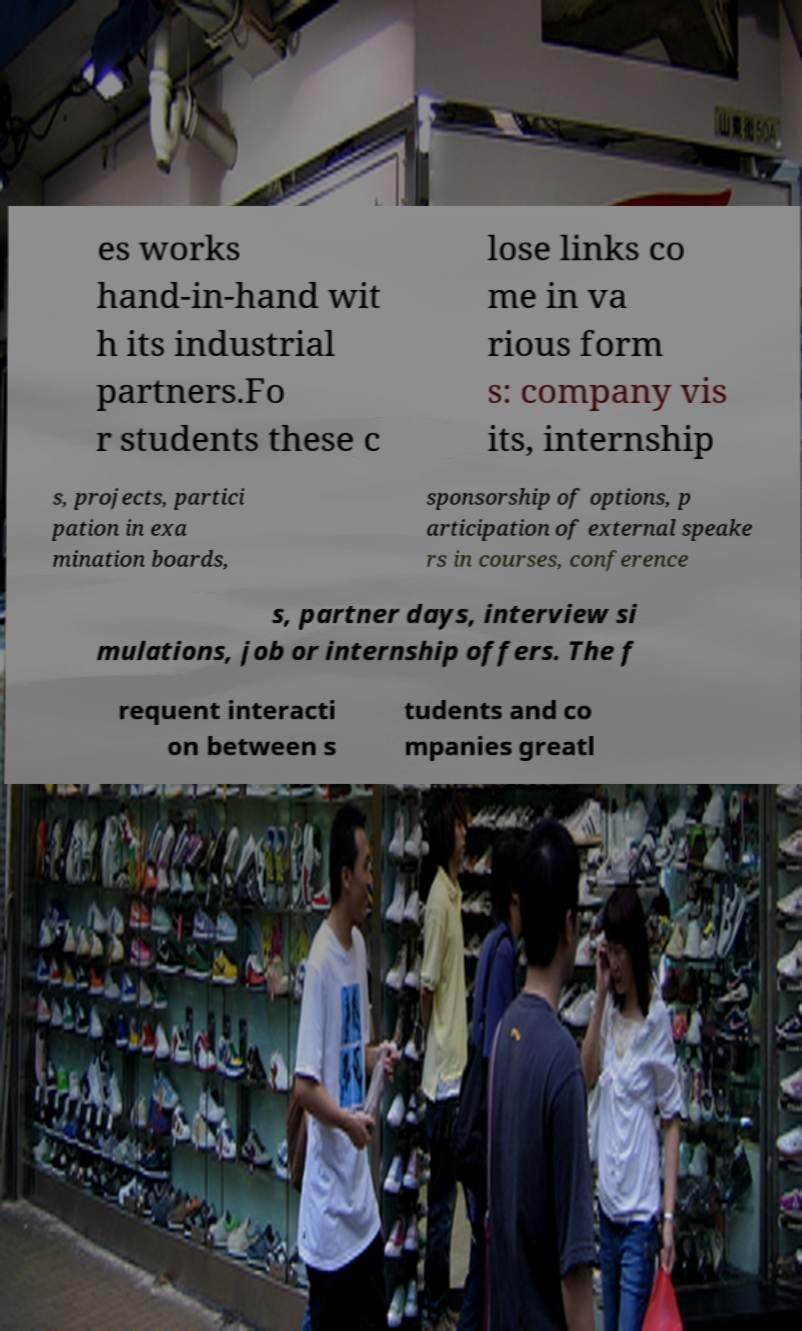Can you accurately transcribe the text from the provided image for me? es works hand-in-hand wit h its industrial partners.Fo r students these c lose links co me in va rious form s: company vis its, internship s, projects, partici pation in exa mination boards, sponsorship of options, p articipation of external speake rs in courses, conference s, partner days, interview si mulations, job or internship offers. The f requent interacti on between s tudents and co mpanies greatl 